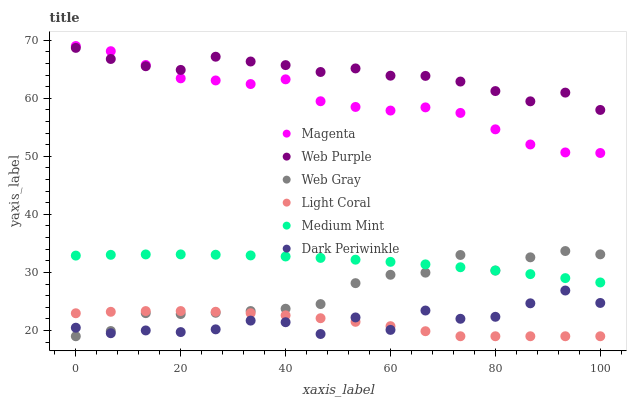Does Light Coral have the minimum area under the curve?
Answer yes or no. Yes. Does Web Purple have the maximum area under the curve?
Answer yes or no. Yes. Does Web Gray have the minimum area under the curve?
Answer yes or no. No. Does Web Gray have the maximum area under the curve?
Answer yes or no. No. Is Medium Mint the smoothest?
Answer yes or no. Yes. Is Dark Periwinkle the roughest?
Answer yes or no. Yes. Is Web Gray the smoothest?
Answer yes or no. No. Is Web Gray the roughest?
Answer yes or no. No. Does Web Gray have the lowest value?
Answer yes or no. Yes. Does Web Purple have the lowest value?
Answer yes or no. No. Does Magenta have the highest value?
Answer yes or no. Yes. Does Web Gray have the highest value?
Answer yes or no. No. Is Dark Periwinkle less than Magenta?
Answer yes or no. Yes. Is Web Purple greater than Dark Periwinkle?
Answer yes or no. Yes. Does Web Gray intersect Light Coral?
Answer yes or no. Yes. Is Web Gray less than Light Coral?
Answer yes or no. No. Is Web Gray greater than Light Coral?
Answer yes or no. No. Does Dark Periwinkle intersect Magenta?
Answer yes or no. No. 